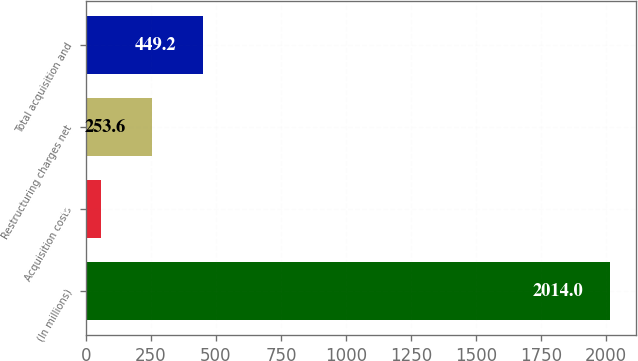Convert chart to OTSL. <chart><loc_0><loc_0><loc_500><loc_500><bar_chart><fcel>(In millions)<fcel>Acquisition costs<fcel>Restructuring charges net<fcel>Total acquisition and<nl><fcel>2014<fcel>58<fcel>253.6<fcel>449.2<nl></chart> 